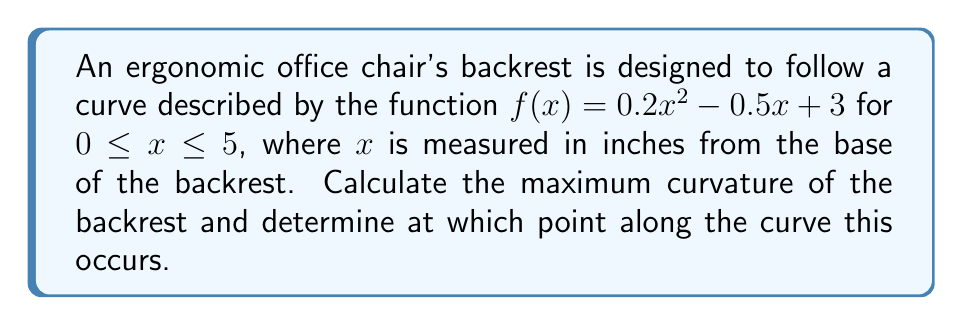What is the answer to this math problem? To solve this problem, we'll follow these steps:

1) The curvature $\kappa$ of a curve $y = f(x)$ is given by the formula:

   $$\kappa = \frac{|f''(x)|}{(1 + (f'(x))^2)^{3/2}}$$

2) First, let's find $f'(x)$ and $f''(x)$:

   $f'(x) = 0.4x - 0.5$
   $f''(x) = 0.4$

3) Now, we can substitute these into our curvature formula:

   $$\kappa = \frac{|0.4|}{(1 + (0.4x - 0.5)^2)^{3/2}}$$

4) To find the maximum curvature, we need to find where the derivative of $\kappa$ with respect to $x$ equals zero. However, we can see that the numerator is constant, so the maximum curvature will occur when the denominator is at its minimum.

5) The denominator will be at its minimum when $(0.4x - 0.5)^2$ is at its minimum, which occurs when $0.4x - 0.5 = 0$.

6) Solving this equation:

   $0.4x - 0.5 = 0$
   $0.4x = 0.5$
   $x = 1.25$

7) Therefore, the maximum curvature occurs at $x = 1.25$ inches from the base of the backrest.

8) To find the value of the maximum curvature, we substitute $x = 1.25$ into our curvature formula:

   $$\kappa_{max} = \frac{0.4}{(1 + (0.4(1.25) - 0.5)^2)^{3/2}} = \frac{0.4}{1^{3/2}} = 0.4$$
Answer: Maximum curvature: 0.4; occurs at 1.25 inches from base 